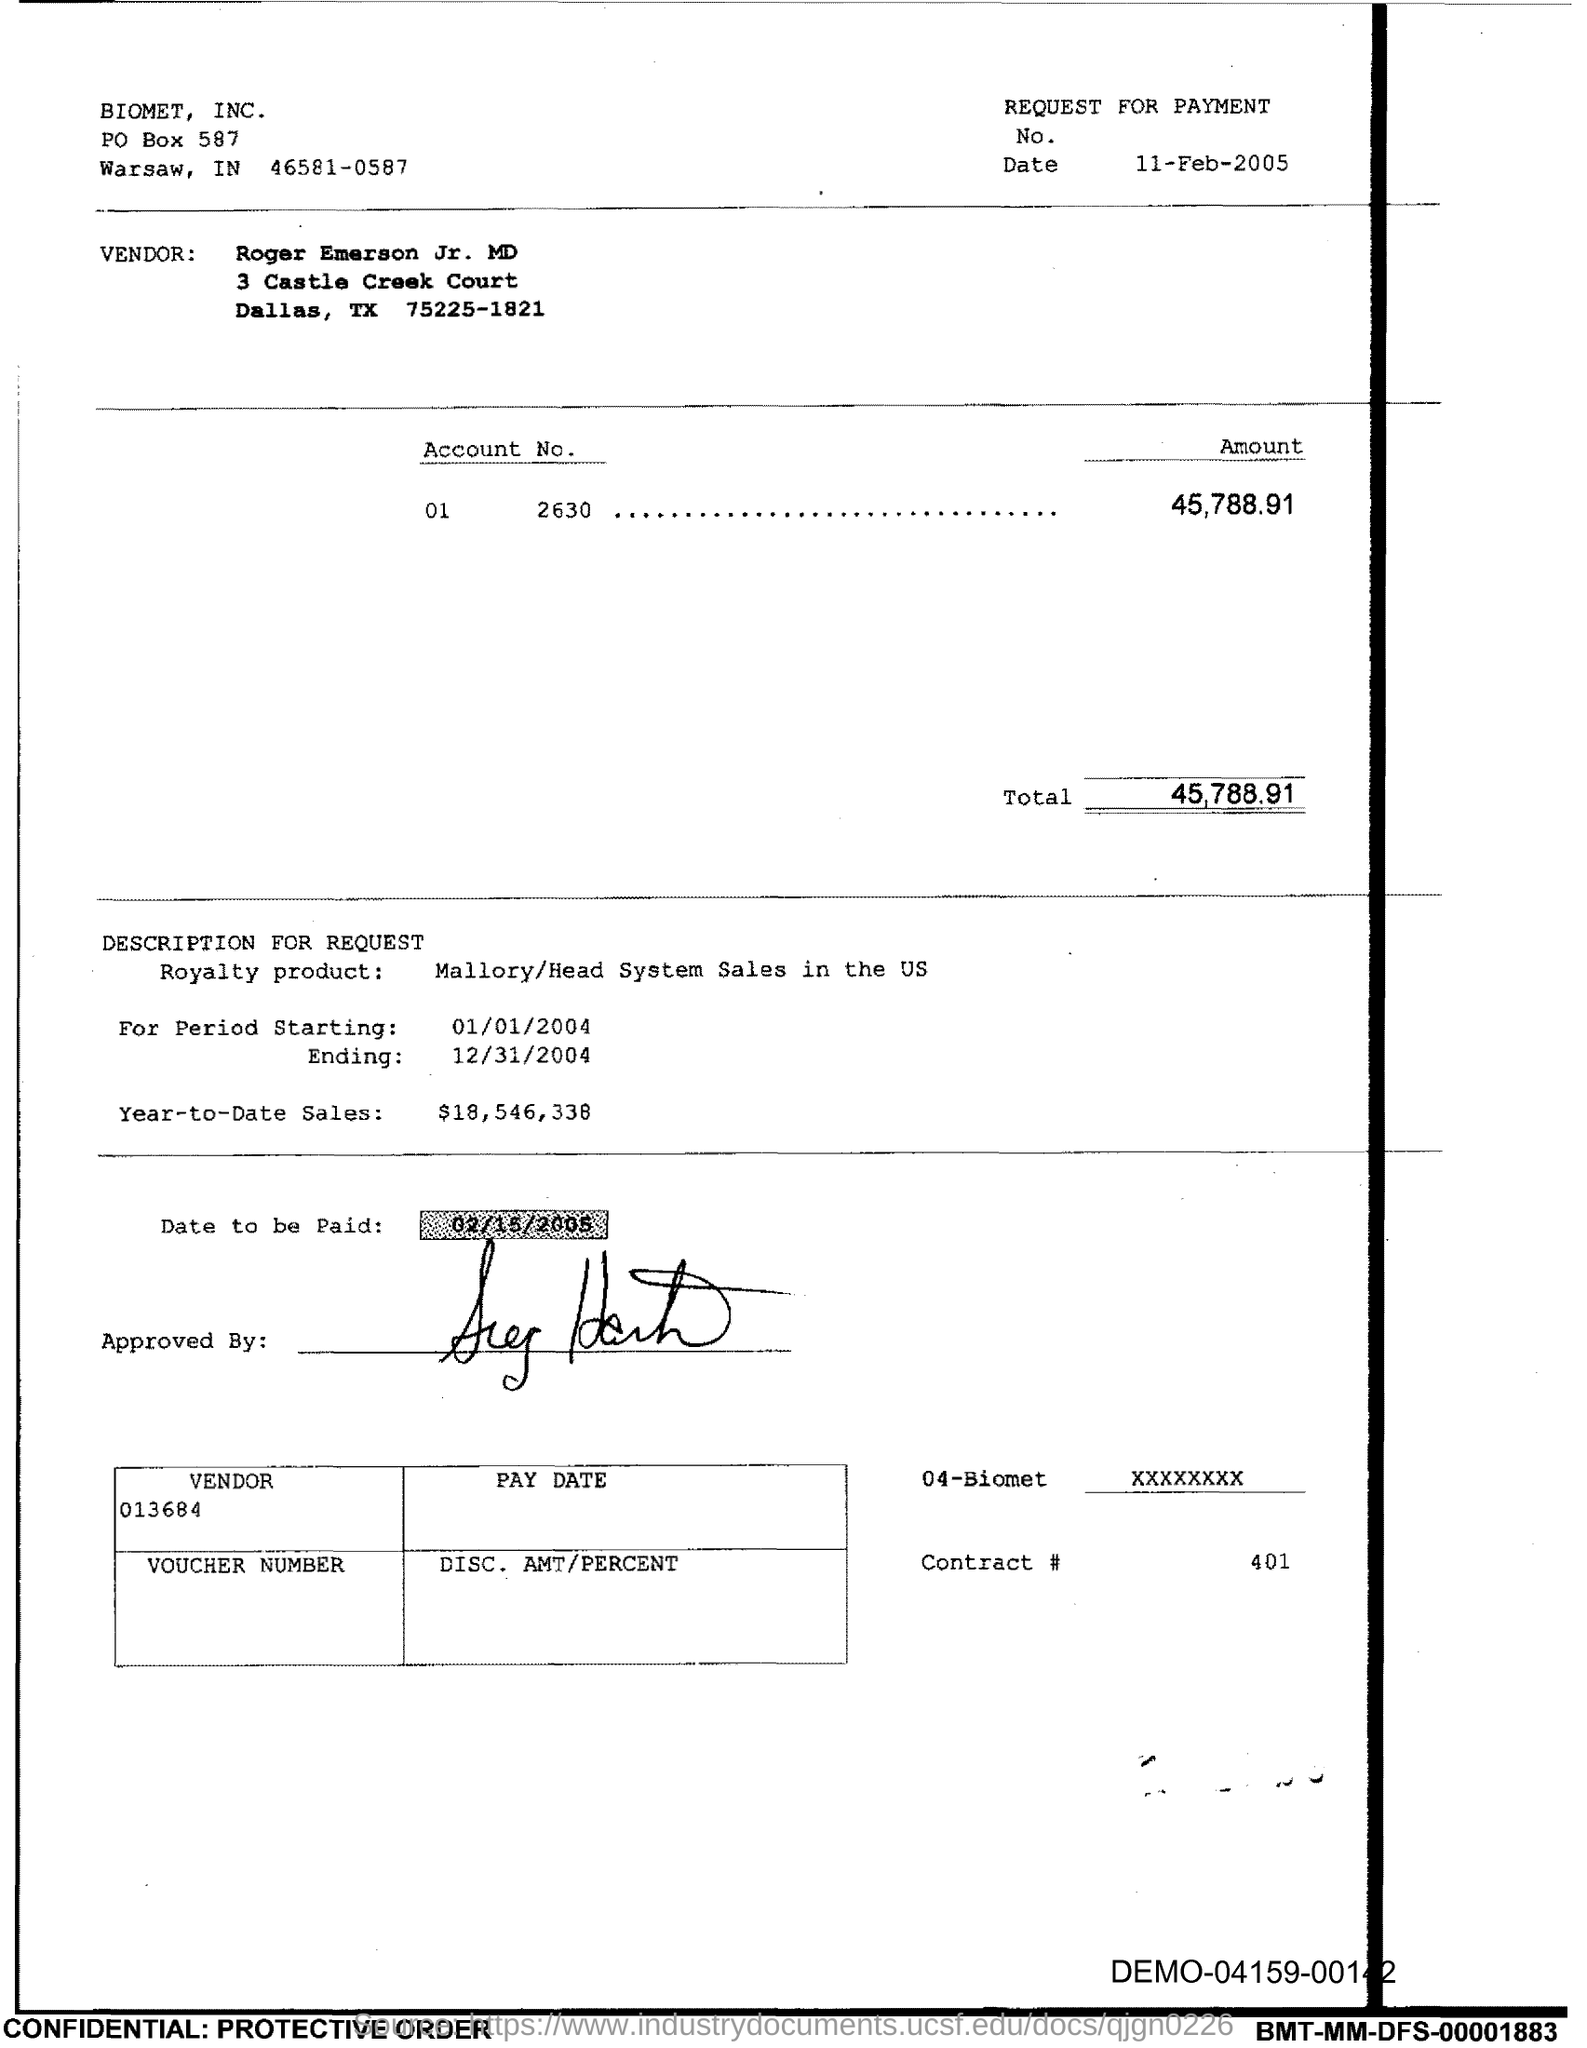Highlight a few significant elements in this photo. What is the Contract Number 401?" is a question. The total is 45,788.91. 